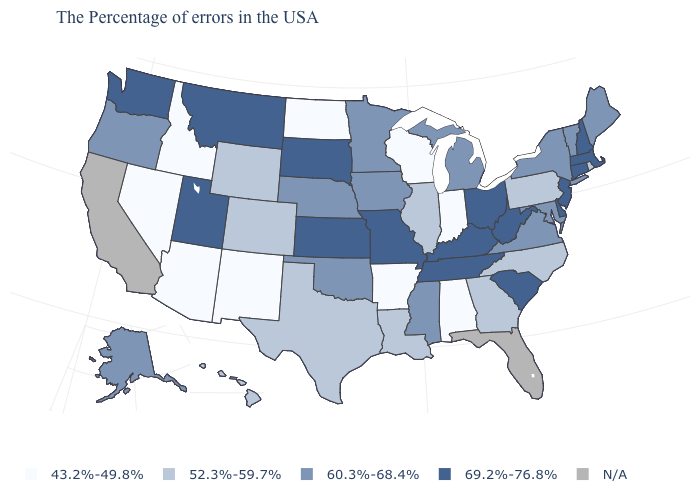What is the value of Delaware?
Write a very short answer. 69.2%-76.8%. What is the value of Georgia?
Give a very brief answer. 52.3%-59.7%. How many symbols are there in the legend?
Keep it brief. 5. Among the states that border North Carolina , does South Carolina have the highest value?
Short answer required. Yes. Which states have the lowest value in the USA?
Keep it brief. Indiana, Alabama, Wisconsin, Arkansas, North Dakota, New Mexico, Arizona, Idaho, Nevada. Name the states that have a value in the range 69.2%-76.8%?
Be succinct. Massachusetts, New Hampshire, Connecticut, New Jersey, Delaware, South Carolina, West Virginia, Ohio, Kentucky, Tennessee, Missouri, Kansas, South Dakota, Utah, Montana, Washington. Does the map have missing data?
Keep it brief. Yes. Name the states that have a value in the range 60.3%-68.4%?
Short answer required. Maine, Vermont, New York, Maryland, Virginia, Michigan, Mississippi, Minnesota, Iowa, Nebraska, Oklahoma, Oregon, Alaska. What is the highest value in the USA?
Give a very brief answer. 69.2%-76.8%. Among the states that border Nevada , which have the highest value?
Quick response, please. Utah. Name the states that have a value in the range 69.2%-76.8%?
Answer briefly. Massachusetts, New Hampshire, Connecticut, New Jersey, Delaware, South Carolina, West Virginia, Ohio, Kentucky, Tennessee, Missouri, Kansas, South Dakota, Utah, Montana, Washington. What is the value of Kansas?
Write a very short answer. 69.2%-76.8%. What is the highest value in the South ?
Answer briefly. 69.2%-76.8%. 